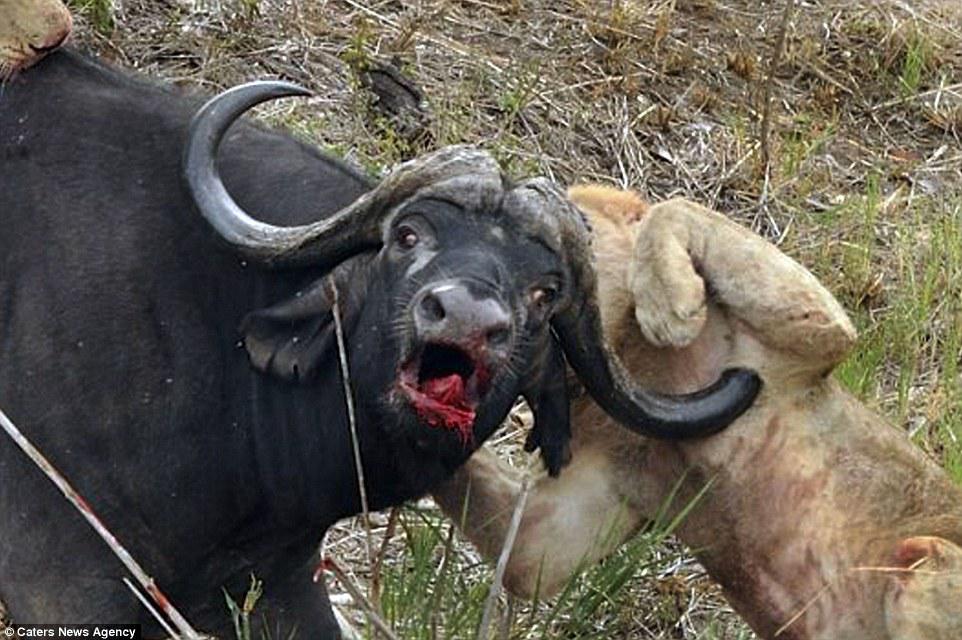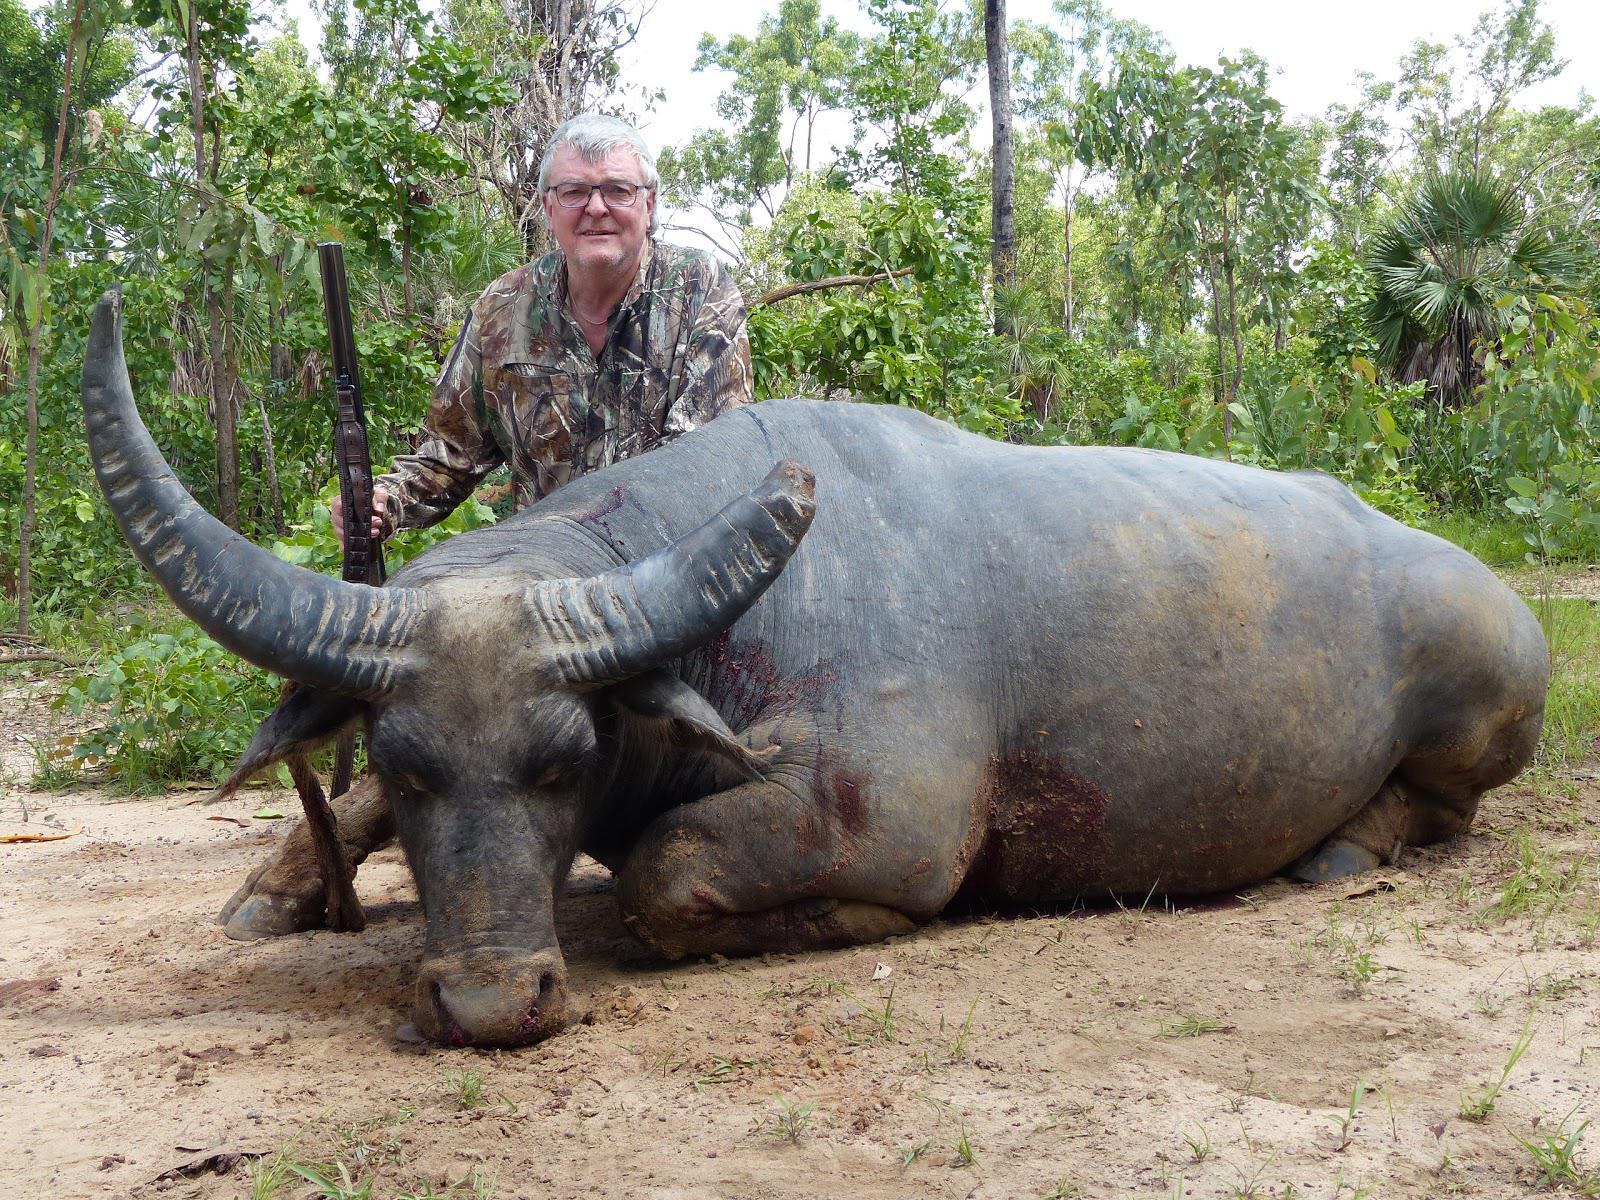The first image is the image on the left, the second image is the image on the right. Considering the images on both sides, is "The right image contains a dead water buffalo in front of a human." valid? Answer yes or no. Yes. The first image is the image on the left, the second image is the image on the right. Considering the images on both sides, is "A non-standing hunter holding a weapon is behind a killed water buffalo that is lying on the ground with its face forward." valid? Answer yes or no. Yes. 